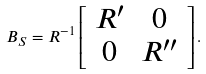<formula> <loc_0><loc_0><loc_500><loc_500>B _ { S } = R ^ { - 1 } \left [ \begin{array} { c c } R ^ { \prime } & 0 \\ 0 & R ^ { \prime \prime } \end{array} \right ] .</formula> 